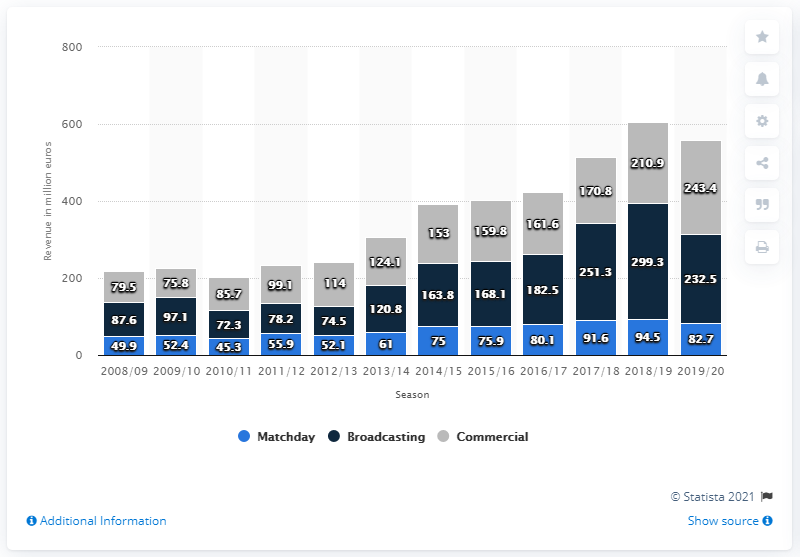Give some essential details in this illustration. In the 2018/2019 season, Liverpool FC earned £299.3 million from broadcasting revenues. In the 2018/2019 fiscal year, Liverpool Football Club generated a total commercial revenue of 210.9 million pounds. 